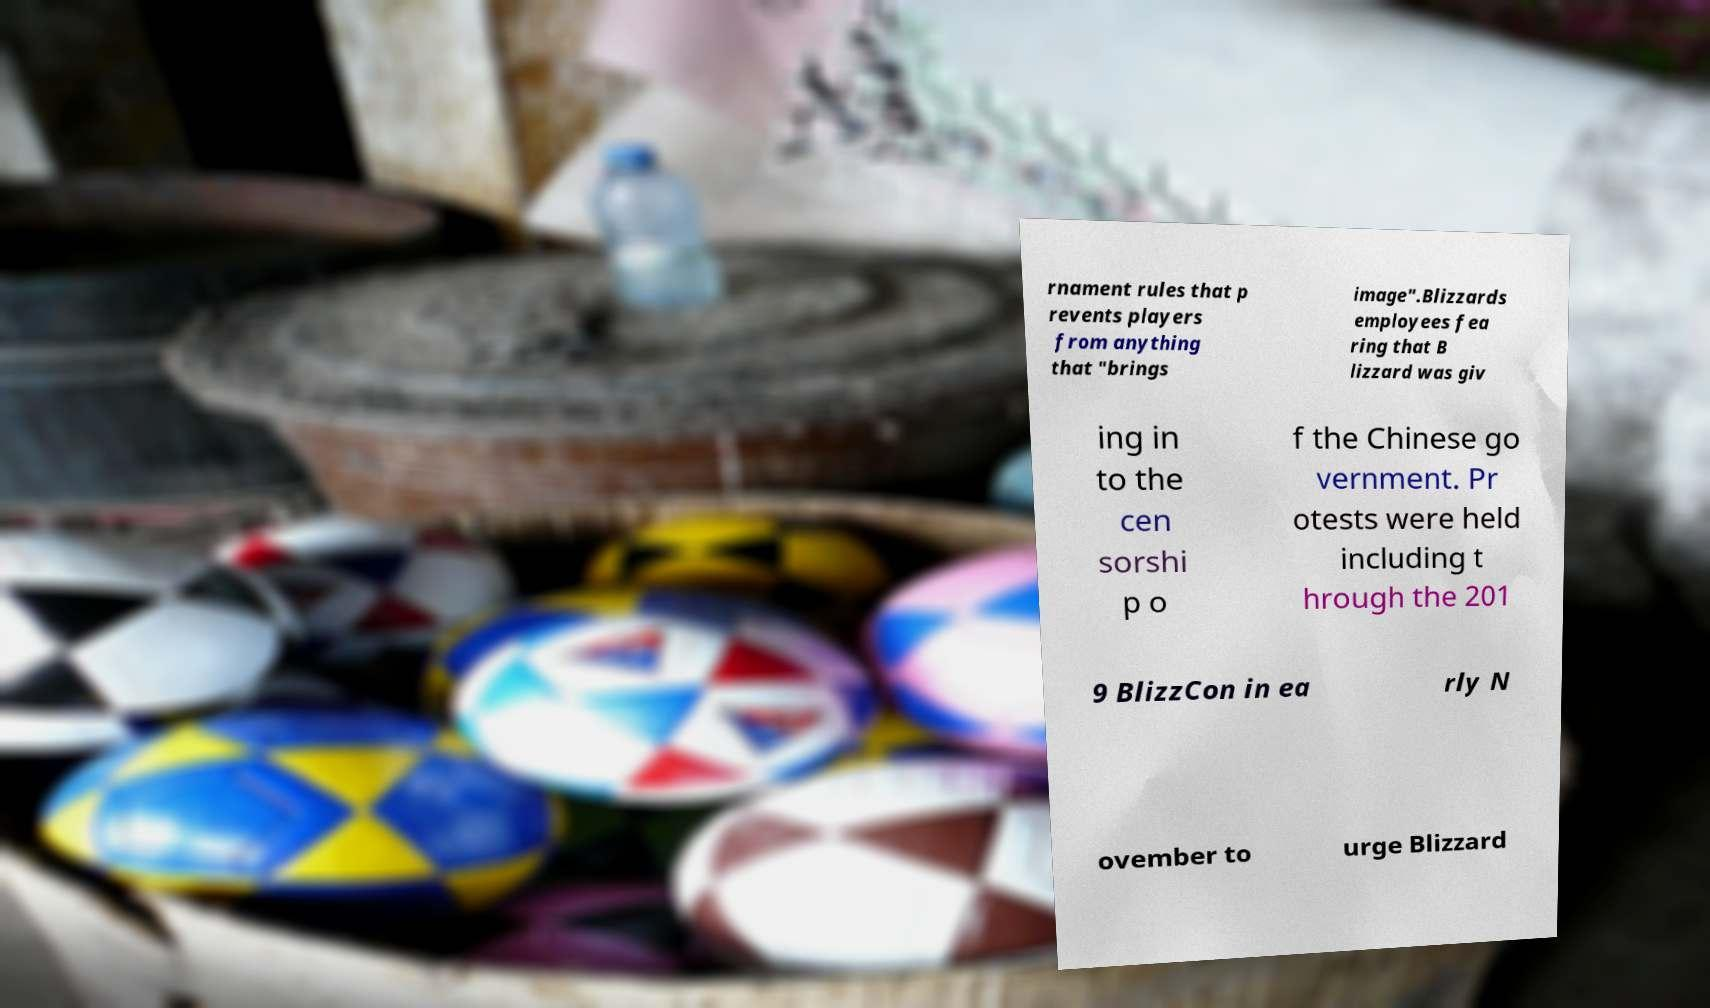There's text embedded in this image that I need extracted. Can you transcribe it verbatim? rnament rules that p revents players from anything that "brings image".Blizzards employees fea ring that B lizzard was giv ing in to the cen sorshi p o f the Chinese go vernment. Pr otests were held including t hrough the 201 9 BlizzCon in ea rly N ovember to urge Blizzard 